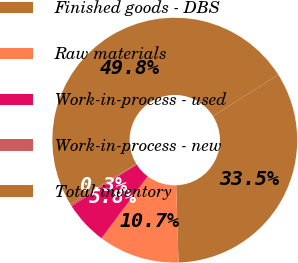Convert chart to OTSL. <chart><loc_0><loc_0><loc_500><loc_500><pie_chart><fcel>Finished goods - DBS<fcel>Raw materials<fcel>Work-in-process - used<fcel>Work-in-process - new<fcel>Total inventory<nl><fcel>33.49%<fcel>10.7%<fcel>5.75%<fcel>0.29%<fcel>49.77%<nl></chart> 